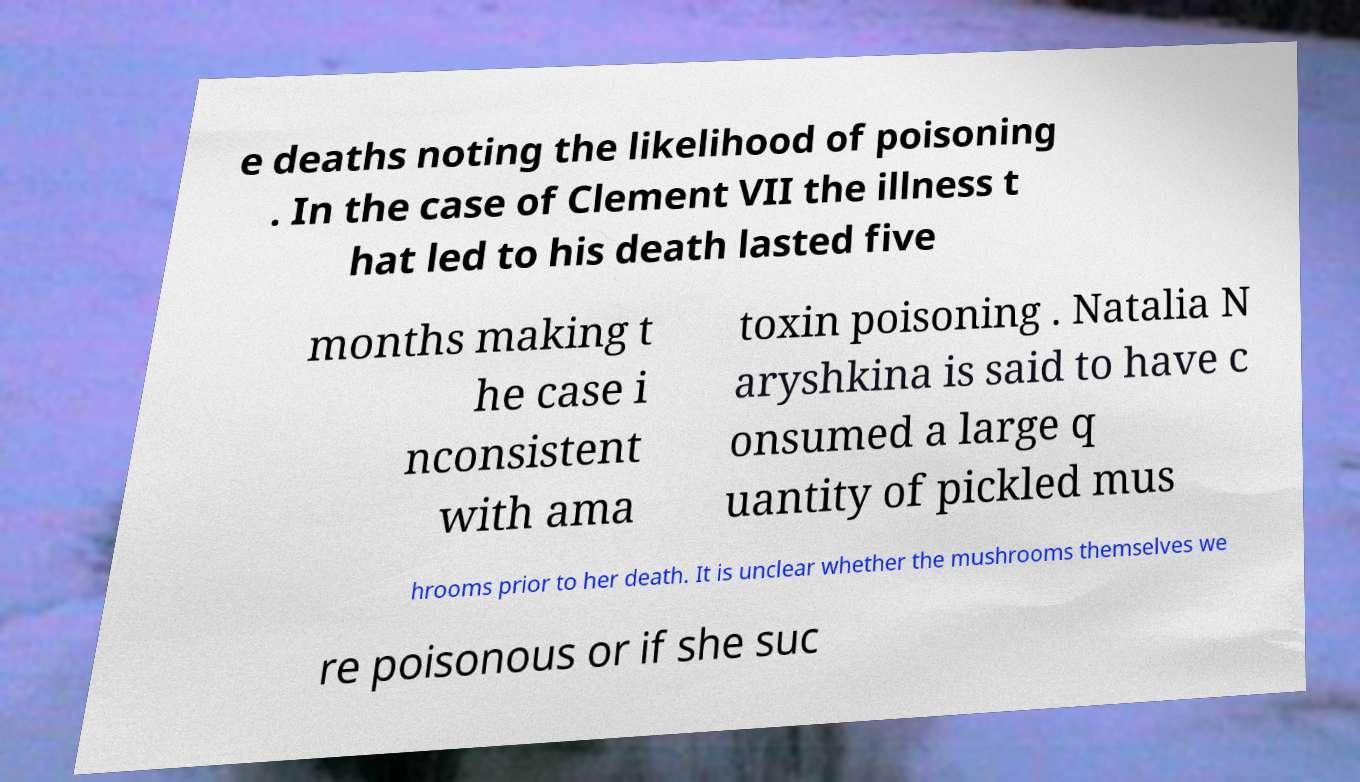I need the written content from this picture converted into text. Can you do that? e deaths noting the likelihood of poisoning . In the case of Clement VII the illness t hat led to his death lasted five months making t he case i nconsistent with ama toxin poisoning . Natalia N aryshkina is said to have c onsumed a large q uantity of pickled mus hrooms prior to her death. It is unclear whether the mushrooms themselves we re poisonous or if she suc 